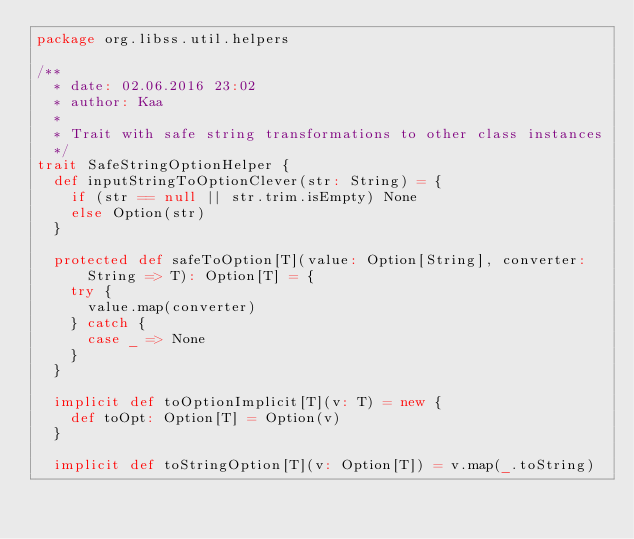<code> <loc_0><loc_0><loc_500><loc_500><_Scala_>package org.libss.util.helpers

/**
  * date: 02.06.2016 23:02
  * author: Kaa
  *
  * Trait with safe string transformations to other class instances
  */
trait SafeStringOptionHelper {
  def inputStringToOptionClever(str: String) = {
    if (str == null || str.trim.isEmpty) None
    else Option(str)
  }

  protected def safeToOption[T](value: Option[String], converter: String => T): Option[T] = {
    try {
      value.map(converter)
    } catch {
      case _ => None
    }
  }

  implicit def toOptionImplicit[T](v: T) = new {
    def toOpt: Option[T] = Option(v)
  }

  implicit def toStringOption[T](v: Option[T]) = v.map(_.toString)
</code> 